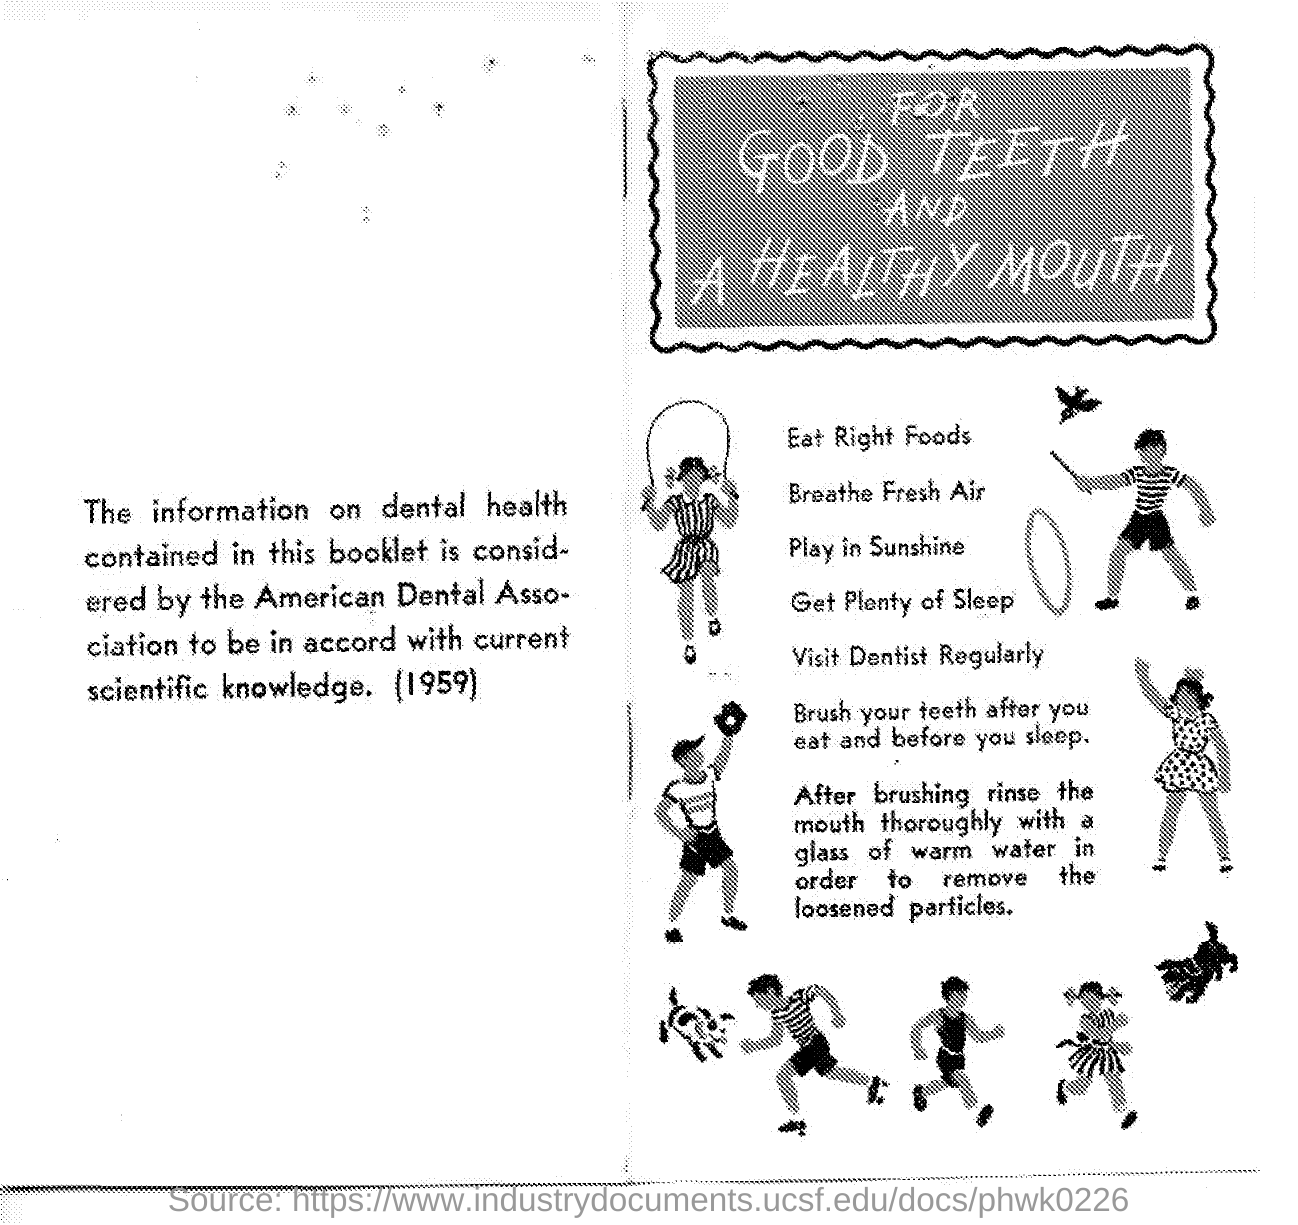What is the title of the document?
Give a very brief answer. For Good Teeth and A Healthy Mouth. What is the year mentioned in the document?
Your answer should be compact. 1959. 